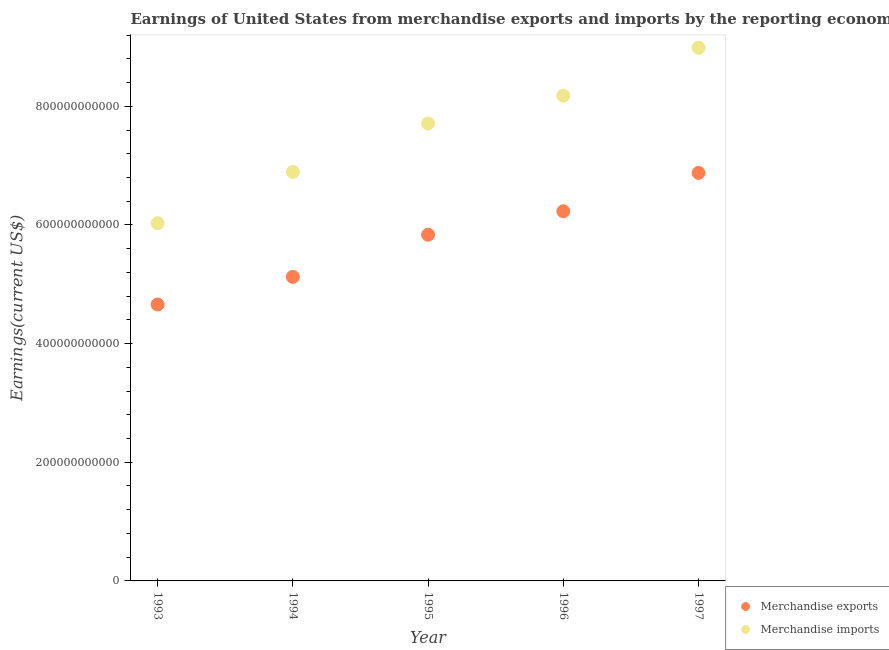Is the number of dotlines equal to the number of legend labels?
Provide a succinct answer. Yes. What is the earnings from merchandise exports in 1995?
Your response must be concise. 5.84e+11. Across all years, what is the maximum earnings from merchandise exports?
Ensure brevity in your answer.  6.88e+11. Across all years, what is the minimum earnings from merchandise exports?
Your answer should be very brief. 4.66e+11. In which year was the earnings from merchandise exports minimum?
Provide a succinct answer. 1993. What is the total earnings from merchandise imports in the graph?
Provide a succinct answer. 3.78e+12. What is the difference between the earnings from merchandise imports in 1993 and that in 1996?
Keep it short and to the point. -2.15e+11. What is the difference between the earnings from merchandise exports in 1996 and the earnings from merchandise imports in 1995?
Keep it short and to the point. -1.48e+11. What is the average earnings from merchandise imports per year?
Offer a very short reply. 7.56e+11. In the year 1995, what is the difference between the earnings from merchandise imports and earnings from merchandise exports?
Provide a short and direct response. 1.88e+11. In how many years, is the earnings from merchandise exports greater than 320000000000 US$?
Your response must be concise. 5. What is the ratio of the earnings from merchandise exports in 1995 to that in 1997?
Provide a short and direct response. 0.85. What is the difference between the highest and the second highest earnings from merchandise imports?
Your answer should be very brief. 8.09e+1. What is the difference between the highest and the lowest earnings from merchandise exports?
Offer a terse response. 2.22e+11. Is the sum of the earnings from merchandise imports in 1993 and 1997 greater than the maximum earnings from merchandise exports across all years?
Your answer should be compact. Yes. Does the earnings from merchandise exports monotonically increase over the years?
Your answer should be very brief. Yes. What is the difference between two consecutive major ticks on the Y-axis?
Make the answer very short. 2.00e+11. Does the graph contain any zero values?
Your answer should be compact. No. Does the graph contain grids?
Provide a succinct answer. No. Where does the legend appear in the graph?
Provide a short and direct response. Bottom right. How are the legend labels stacked?
Your response must be concise. Vertical. What is the title of the graph?
Provide a succinct answer. Earnings of United States from merchandise exports and imports by the reporting economy. What is the label or title of the X-axis?
Your answer should be compact. Year. What is the label or title of the Y-axis?
Offer a terse response. Earnings(current US$). What is the Earnings(current US$) in Merchandise exports in 1993?
Provide a succinct answer. 4.66e+11. What is the Earnings(current US$) in Merchandise imports in 1993?
Keep it short and to the point. 6.03e+11. What is the Earnings(current US$) of Merchandise exports in 1994?
Provide a succinct answer. 5.12e+11. What is the Earnings(current US$) in Merchandise imports in 1994?
Provide a short and direct response. 6.89e+11. What is the Earnings(current US$) in Merchandise exports in 1995?
Provide a short and direct response. 5.84e+11. What is the Earnings(current US$) in Merchandise imports in 1995?
Ensure brevity in your answer.  7.71e+11. What is the Earnings(current US$) in Merchandise exports in 1996?
Your answer should be compact. 6.23e+11. What is the Earnings(current US$) in Merchandise imports in 1996?
Make the answer very short. 8.18e+11. What is the Earnings(current US$) of Merchandise exports in 1997?
Offer a very short reply. 6.88e+11. What is the Earnings(current US$) in Merchandise imports in 1997?
Provide a short and direct response. 8.99e+11. Across all years, what is the maximum Earnings(current US$) in Merchandise exports?
Offer a terse response. 6.88e+11. Across all years, what is the maximum Earnings(current US$) in Merchandise imports?
Offer a terse response. 8.99e+11. Across all years, what is the minimum Earnings(current US$) of Merchandise exports?
Your answer should be compact. 4.66e+11. Across all years, what is the minimum Earnings(current US$) in Merchandise imports?
Offer a terse response. 6.03e+11. What is the total Earnings(current US$) of Merchandise exports in the graph?
Your answer should be compact. 2.87e+12. What is the total Earnings(current US$) in Merchandise imports in the graph?
Ensure brevity in your answer.  3.78e+12. What is the difference between the Earnings(current US$) of Merchandise exports in 1993 and that in 1994?
Make the answer very short. -4.65e+1. What is the difference between the Earnings(current US$) of Merchandise imports in 1993 and that in 1994?
Your response must be concise. -8.64e+1. What is the difference between the Earnings(current US$) of Merchandise exports in 1993 and that in 1995?
Keep it short and to the point. -1.18e+11. What is the difference between the Earnings(current US$) in Merchandise imports in 1993 and that in 1995?
Your response must be concise. -1.68e+11. What is the difference between the Earnings(current US$) in Merchandise exports in 1993 and that in 1996?
Give a very brief answer. -1.57e+11. What is the difference between the Earnings(current US$) in Merchandise imports in 1993 and that in 1996?
Provide a succinct answer. -2.15e+11. What is the difference between the Earnings(current US$) in Merchandise exports in 1993 and that in 1997?
Your answer should be very brief. -2.22e+11. What is the difference between the Earnings(current US$) of Merchandise imports in 1993 and that in 1997?
Offer a terse response. -2.96e+11. What is the difference between the Earnings(current US$) of Merchandise exports in 1994 and that in 1995?
Provide a succinct answer. -7.11e+1. What is the difference between the Earnings(current US$) of Merchandise imports in 1994 and that in 1995?
Make the answer very short. -8.17e+1. What is the difference between the Earnings(current US$) of Merchandise exports in 1994 and that in 1996?
Offer a very short reply. -1.11e+11. What is the difference between the Earnings(current US$) in Merchandise imports in 1994 and that in 1996?
Provide a short and direct response. -1.28e+11. What is the difference between the Earnings(current US$) in Merchandise exports in 1994 and that in 1997?
Your answer should be compact. -1.75e+11. What is the difference between the Earnings(current US$) in Merchandise imports in 1994 and that in 1997?
Provide a succinct answer. -2.09e+11. What is the difference between the Earnings(current US$) in Merchandise exports in 1995 and that in 1996?
Your response must be concise. -3.95e+1. What is the difference between the Earnings(current US$) of Merchandise imports in 1995 and that in 1996?
Provide a succinct answer. -4.68e+1. What is the difference between the Earnings(current US$) in Merchandise exports in 1995 and that in 1997?
Keep it short and to the point. -1.04e+11. What is the difference between the Earnings(current US$) of Merchandise imports in 1995 and that in 1997?
Offer a very short reply. -1.28e+11. What is the difference between the Earnings(current US$) in Merchandise exports in 1996 and that in 1997?
Your answer should be very brief. -6.46e+1. What is the difference between the Earnings(current US$) of Merchandise imports in 1996 and that in 1997?
Your answer should be compact. -8.09e+1. What is the difference between the Earnings(current US$) of Merchandise exports in 1993 and the Earnings(current US$) of Merchandise imports in 1994?
Provide a succinct answer. -2.23e+11. What is the difference between the Earnings(current US$) in Merchandise exports in 1993 and the Earnings(current US$) in Merchandise imports in 1995?
Offer a terse response. -3.05e+11. What is the difference between the Earnings(current US$) in Merchandise exports in 1993 and the Earnings(current US$) in Merchandise imports in 1996?
Offer a very short reply. -3.52e+11. What is the difference between the Earnings(current US$) of Merchandise exports in 1993 and the Earnings(current US$) of Merchandise imports in 1997?
Offer a terse response. -4.33e+11. What is the difference between the Earnings(current US$) of Merchandise exports in 1994 and the Earnings(current US$) of Merchandise imports in 1995?
Offer a terse response. -2.59e+11. What is the difference between the Earnings(current US$) of Merchandise exports in 1994 and the Earnings(current US$) of Merchandise imports in 1996?
Your answer should be compact. -3.05e+11. What is the difference between the Earnings(current US$) in Merchandise exports in 1994 and the Earnings(current US$) in Merchandise imports in 1997?
Offer a very short reply. -3.86e+11. What is the difference between the Earnings(current US$) of Merchandise exports in 1995 and the Earnings(current US$) of Merchandise imports in 1996?
Ensure brevity in your answer.  -2.34e+11. What is the difference between the Earnings(current US$) in Merchandise exports in 1995 and the Earnings(current US$) in Merchandise imports in 1997?
Your answer should be compact. -3.15e+11. What is the difference between the Earnings(current US$) in Merchandise exports in 1996 and the Earnings(current US$) in Merchandise imports in 1997?
Make the answer very short. -2.76e+11. What is the average Earnings(current US$) of Merchandise exports per year?
Offer a very short reply. 5.75e+11. What is the average Earnings(current US$) in Merchandise imports per year?
Your response must be concise. 7.56e+11. In the year 1993, what is the difference between the Earnings(current US$) in Merchandise exports and Earnings(current US$) in Merchandise imports?
Give a very brief answer. -1.37e+11. In the year 1994, what is the difference between the Earnings(current US$) of Merchandise exports and Earnings(current US$) of Merchandise imports?
Your response must be concise. -1.77e+11. In the year 1995, what is the difference between the Earnings(current US$) of Merchandise exports and Earnings(current US$) of Merchandise imports?
Your answer should be compact. -1.88e+11. In the year 1996, what is the difference between the Earnings(current US$) of Merchandise exports and Earnings(current US$) of Merchandise imports?
Offer a terse response. -1.95e+11. In the year 1997, what is the difference between the Earnings(current US$) in Merchandise exports and Earnings(current US$) in Merchandise imports?
Offer a terse response. -2.11e+11. What is the ratio of the Earnings(current US$) of Merchandise exports in 1993 to that in 1994?
Your answer should be compact. 0.91. What is the ratio of the Earnings(current US$) of Merchandise imports in 1993 to that in 1994?
Provide a short and direct response. 0.87. What is the ratio of the Earnings(current US$) in Merchandise exports in 1993 to that in 1995?
Your answer should be very brief. 0.8. What is the ratio of the Earnings(current US$) of Merchandise imports in 1993 to that in 1995?
Keep it short and to the point. 0.78. What is the ratio of the Earnings(current US$) in Merchandise exports in 1993 to that in 1996?
Provide a succinct answer. 0.75. What is the ratio of the Earnings(current US$) of Merchandise imports in 1993 to that in 1996?
Give a very brief answer. 0.74. What is the ratio of the Earnings(current US$) in Merchandise exports in 1993 to that in 1997?
Provide a succinct answer. 0.68. What is the ratio of the Earnings(current US$) of Merchandise imports in 1993 to that in 1997?
Provide a succinct answer. 0.67. What is the ratio of the Earnings(current US$) in Merchandise exports in 1994 to that in 1995?
Offer a terse response. 0.88. What is the ratio of the Earnings(current US$) in Merchandise imports in 1994 to that in 1995?
Provide a short and direct response. 0.89. What is the ratio of the Earnings(current US$) of Merchandise exports in 1994 to that in 1996?
Keep it short and to the point. 0.82. What is the ratio of the Earnings(current US$) in Merchandise imports in 1994 to that in 1996?
Keep it short and to the point. 0.84. What is the ratio of the Earnings(current US$) in Merchandise exports in 1994 to that in 1997?
Keep it short and to the point. 0.75. What is the ratio of the Earnings(current US$) of Merchandise imports in 1994 to that in 1997?
Your response must be concise. 0.77. What is the ratio of the Earnings(current US$) of Merchandise exports in 1995 to that in 1996?
Offer a very short reply. 0.94. What is the ratio of the Earnings(current US$) in Merchandise imports in 1995 to that in 1996?
Keep it short and to the point. 0.94. What is the ratio of the Earnings(current US$) in Merchandise exports in 1995 to that in 1997?
Your answer should be very brief. 0.85. What is the ratio of the Earnings(current US$) in Merchandise imports in 1995 to that in 1997?
Provide a short and direct response. 0.86. What is the ratio of the Earnings(current US$) in Merchandise exports in 1996 to that in 1997?
Make the answer very short. 0.91. What is the ratio of the Earnings(current US$) in Merchandise imports in 1996 to that in 1997?
Make the answer very short. 0.91. What is the difference between the highest and the second highest Earnings(current US$) in Merchandise exports?
Provide a succinct answer. 6.46e+1. What is the difference between the highest and the second highest Earnings(current US$) of Merchandise imports?
Ensure brevity in your answer.  8.09e+1. What is the difference between the highest and the lowest Earnings(current US$) in Merchandise exports?
Your response must be concise. 2.22e+11. What is the difference between the highest and the lowest Earnings(current US$) in Merchandise imports?
Provide a succinct answer. 2.96e+11. 